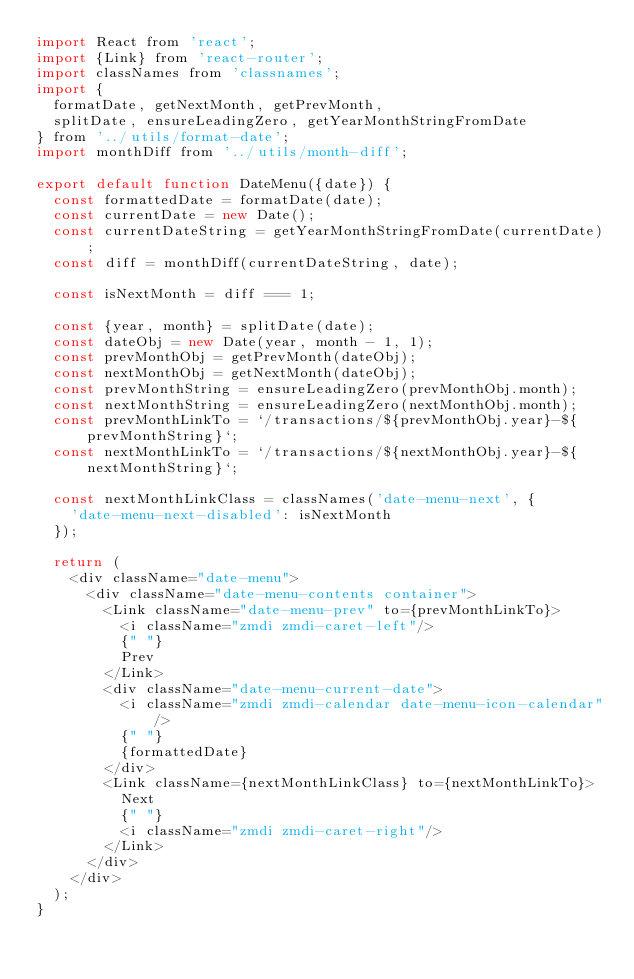Convert code to text. <code><loc_0><loc_0><loc_500><loc_500><_JavaScript_>import React from 'react';
import {Link} from 'react-router';
import classNames from 'classnames';
import {
  formatDate, getNextMonth, getPrevMonth,
  splitDate, ensureLeadingZero, getYearMonthStringFromDate
} from '../utils/format-date';
import monthDiff from '../utils/month-diff';

export default function DateMenu({date}) {
  const formattedDate = formatDate(date);
  const currentDate = new Date();
  const currentDateString = getYearMonthStringFromDate(currentDate);
  const diff = monthDiff(currentDateString, date);

  const isNextMonth = diff === 1;

  const {year, month} = splitDate(date);
  const dateObj = new Date(year, month - 1, 1);
  const prevMonthObj = getPrevMonth(dateObj);
  const nextMonthObj = getNextMonth(dateObj);
  const prevMonthString = ensureLeadingZero(prevMonthObj.month);
  const nextMonthString = ensureLeadingZero(nextMonthObj.month);
  const prevMonthLinkTo = `/transactions/${prevMonthObj.year}-${prevMonthString}`;
  const nextMonthLinkTo = `/transactions/${nextMonthObj.year}-${nextMonthString}`;

  const nextMonthLinkClass = classNames('date-menu-next', {
    'date-menu-next-disabled': isNextMonth
  });

  return (
    <div className="date-menu">
      <div className="date-menu-contents container">
        <Link className="date-menu-prev" to={prevMonthLinkTo}>
          <i className="zmdi zmdi-caret-left"/>
          {" "}
          Prev
        </Link>
        <div className="date-menu-current-date">
          <i className="zmdi zmdi-calendar date-menu-icon-calendar"/>
          {" "}
          {formattedDate}
        </div>
        <Link className={nextMonthLinkClass} to={nextMonthLinkTo}>
          Next
          {" "}
          <i className="zmdi zmdi-caret-right"/>
        </Link>
      </div>
    </div>
  );
}
</code> 